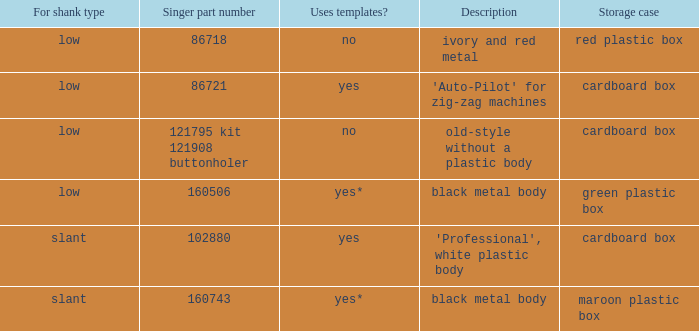What's the shank type of the buttonholer with red plastic box as storage case? Low. 